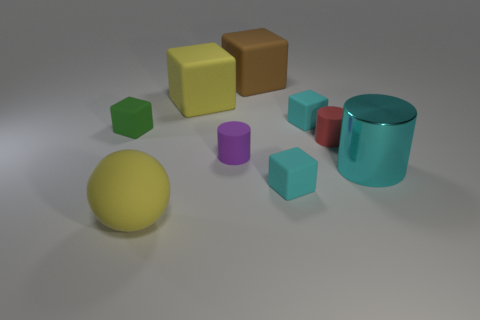Subtract all yellow matte blocks. How many blocks are left? 4 Subtract all red balls. How many cyan cubes are left? 2 Subtract 3 blocks. How many blocks are left? 2 Add 1 small cyan cubes. How many objects exist? 10 Subtract all purple cylinders. How many cylinders are left? 2 Add 2 cubes. How many cubes exist? 7 Subtract 0 red balls. How many objects are left? 9 Subtract all spheres. How many objects are left? 8 Subtract all blue balls. Subtract all red cubes. How many balls are left? 1 Subtract all large purple rubber balls. Subtract all big yellow cubes. How many objects are left? 8 